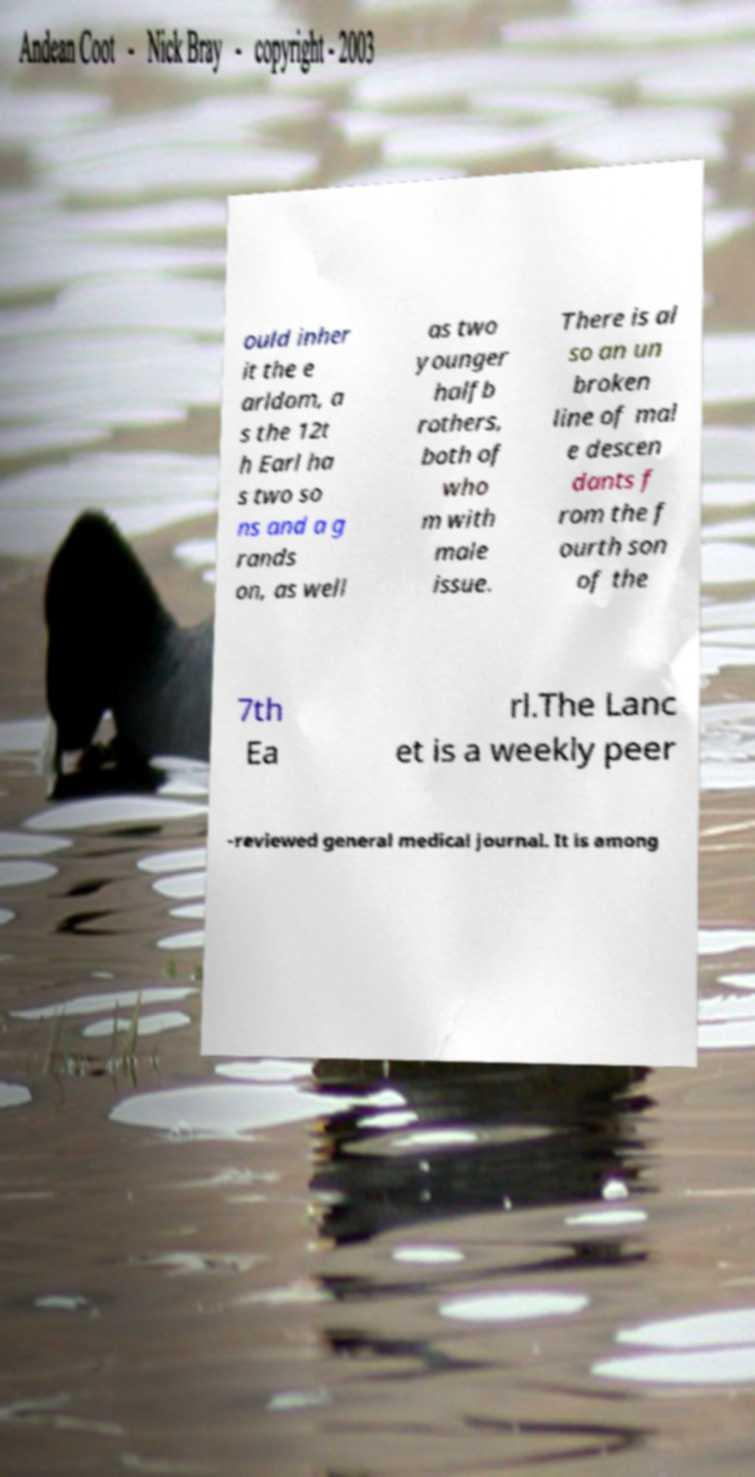Can you accurately transcribe the text from the provided image for me? ould inher it the e arldom, a s the 12t h Earl ha s two so ns and a g rands on, as well as two younger halfb rothers, both of who m with male issue. There is al so an un broken line of mal e descen dants f rom the f ourth son of the 7th Ea rl.The Lanc et is a weekly peer -reviewed general medical journal. It is among 